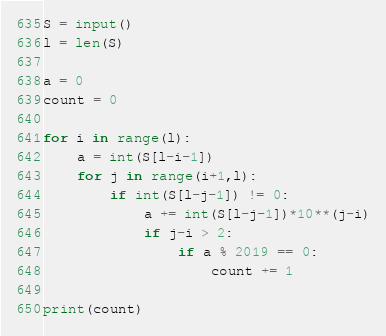Convert code to text. <code><loc_0><loc_0><loc_500><loc_500><_Python_>S = input()
l = len(S)

a = 0
count = 0

for i in range(l):
    a = int(S[l-i-1])
    for j in range(i+1,l):
        if int(S[l-j-1]) != 0:
            a += int(S[l-j-1])*10**(j-i)
            if j-i > 2:
                if a % 2019 == 0:
                    count += 1
            
print(count)</code> 